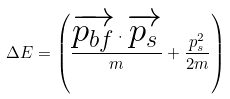Convert formula to latex. <formula><loc_0><loc_0><loc_500><loc_500>\Delta E = \left ( \frac { \overrightarrow { p _ { b f } } \cdot \overrightarrow { p _ { s } } } { m } + \frac { p _ { s } ^ { 2 } } { 2 m } \right )</formula> 